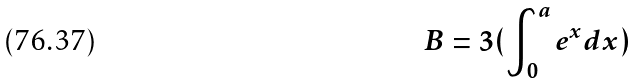Convert formula to latex. <formula><loc_0><loc_0><loc_500><loc_500>B = 3 ( \int _ { 0 } ^ { a } e ^ { x } d x )</formula> 